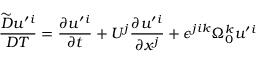Convert formula to latex. <formula><loc_0><loc_0><loc_500><loc_500>\frac { \widetilde { D } u ^ { \prime ^ { i } } { D T } = \frac { \partial u ^ { \prime ^ { i } } { \partial t } + U ^ { j } \frac { \partial u ^ { \prime ^ { i } } { \partial x ^ { j } } + \epsilon ^ { j i k } \Omega _ { 0 } ^ { k } u ^ { \prime ^ { i }</formula> 